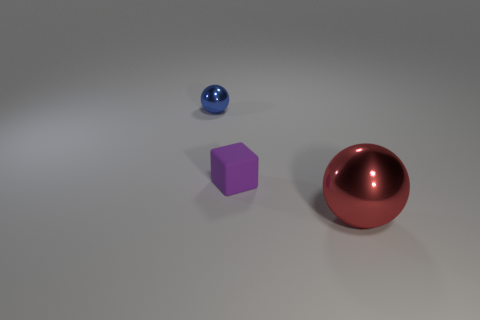Are there any other things that have the same material as the block?
Offer a terse response. No. Is there anything else that is the same size as the red shiny object?
Provide a short and direct response. No. Is there anything else that has the same shape as the purple matte object?
Your response must be concise. No. Is the shape of the small thing right of the blue metallic object the same as  the big shiny object?
Your answer should be compact. No. How many other things are the same shape as the blue metal thing?
Make the answer very short. 1. What is the shape of the tiny thing to the right of the small shiny thing?
Provide a succinct answer. Cube. Is there another small block made of the same material as the purple block?
Ensure brevity in your answer.  No. There is a shiny ball that is in front of the small blue metallic ball; is it the same color as the small matte block?
Your response must be concise. No. How big is the red thing?
Provide a short and direct response. Large. Are there any tiny purple blocks left of the ball behind the shiny ball that is to the right of the small blue metal object?
Your answer should be compact. No. 